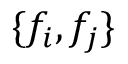<formula> <loc_0><loc_0><loc_500><loc_500>\{ f _ { i } , f _ { j } \}</formula> 